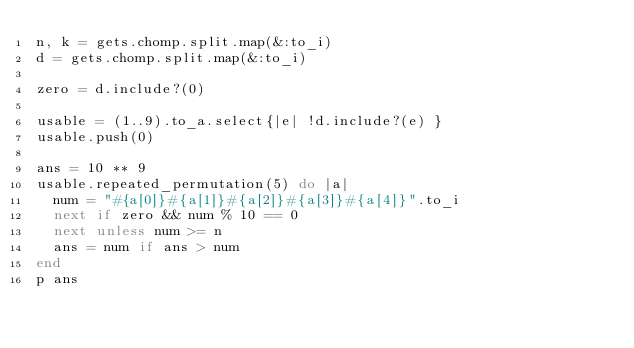<code> <loc_0><loc_0><loc_500><loc_500><_Ruby_>n, k = gets.chomp.split.map(&:to_i)
d = gets.chomp.split.map(&:to_i)

zero = d.include?(0)

usable = (1..9).to_a.select{|e| !d.include?(e) }
usable.push(0)

ans = 10 ** 9
usable.repeated_permutation(5) do |a|
  num = "#{a[0]}#{a[1]}#{a[2]}#{a[3]}#{a[4]}".to_i
  next if zero && num % 10 == 0
  next unless num >= n
  ans = num if ans > num
end
p ans
</code> 